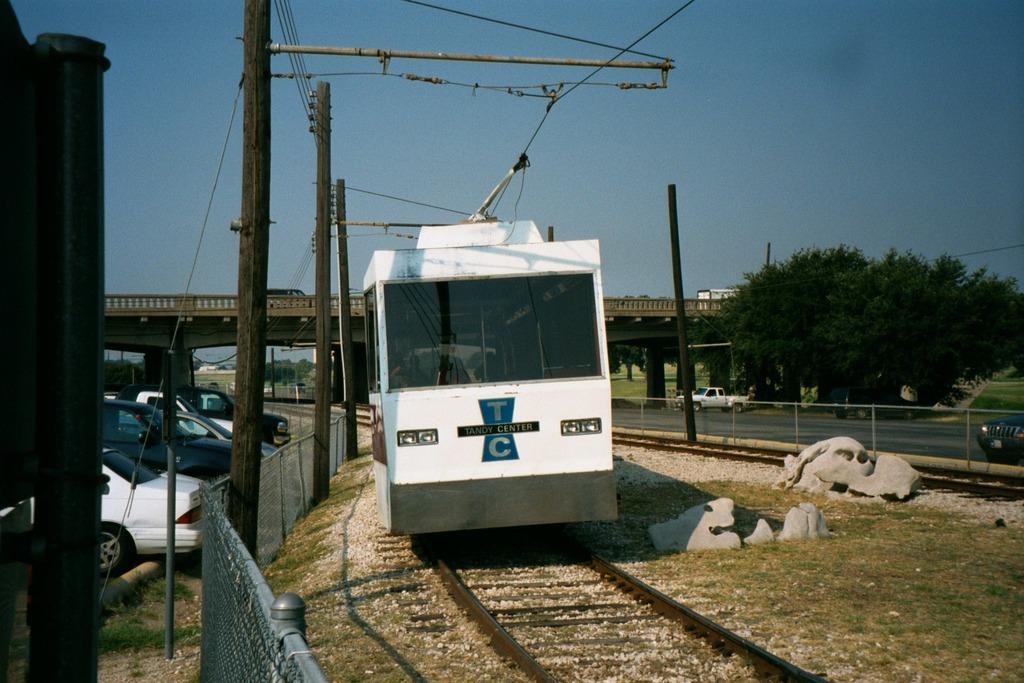How would you summarize this image in a sentence or two? This image is taken outdoors. A the top of the image there is the sky. At the bottom of the image there is the ground with grass on it and there is a railway track. In the background there is a bridge with pillars and a railing. A few vehicles are moving on the bridge. On the right side of the image there are a few trees. There is a fence. There is a pole and two cars are moving on the road. In the middle of the image a train is moving on the track and there are a few stones on the ground. On the left side of the image many cars are parked on the ground and there is a pole. There are a few poles with wires. 